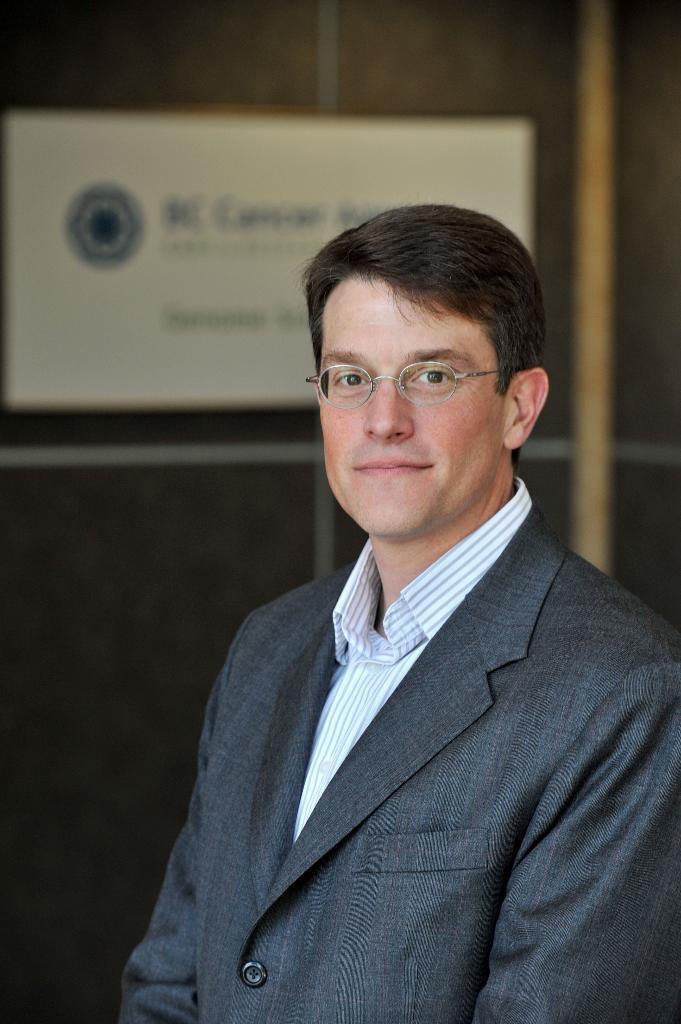How would you summarize this image in a sentence or two? In the image there is a man with spectacles is standing. Behind him there is a wall with poster on it. 